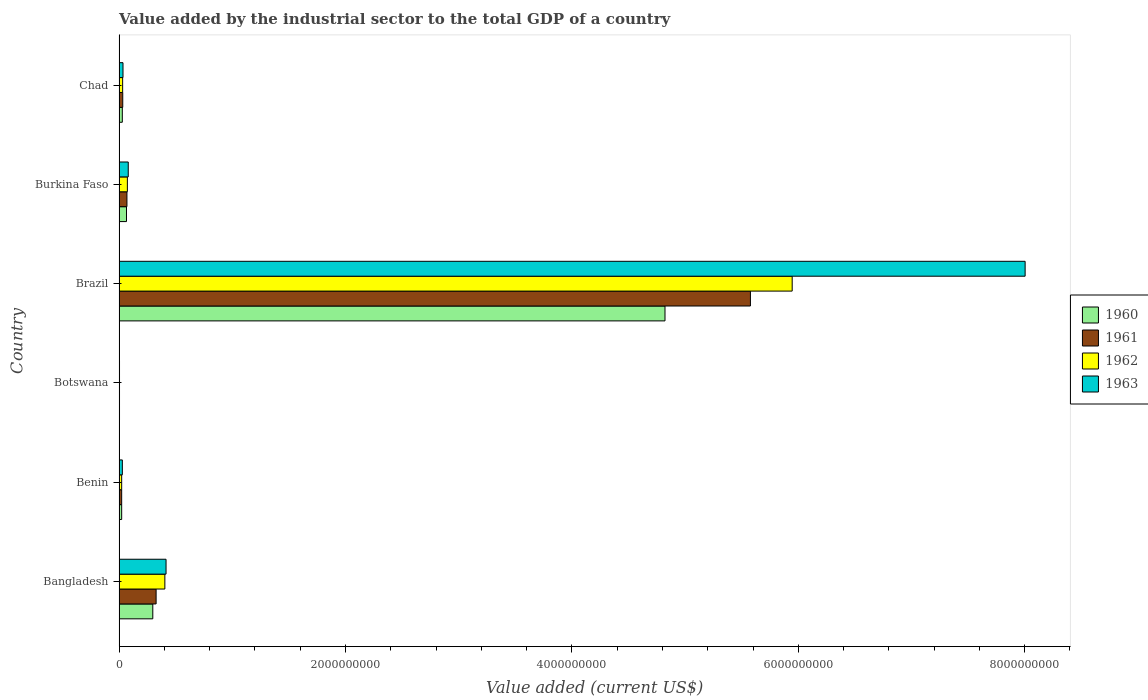How many different coloured bars are there?
Keep it short and to the point. 4. How many groups of bars are there?
Your answer should be very brief. 6. Are the number of bars on each tick of the Y-axis equal?
Give a very brief answer. Yes. How many bars are there on the 5th tick from the top?
Provide a short and direct response. 4. How many bars are there on the 1st tick from the bottom?
Your response must be concise. 4. What is the label of the 5th group of bars from the top?
Keep it short and to the point. Benin. What is the value added by the industrial sector to the total GDP in 1961 in Botswana?
Offer a very short reply. 4.05e+06. Across all countries, what is the maximum value added by the industrial sector to the total GDP in 1962?
Your response must be concise. 5.95e+09. Across all countries, what is the minimum value added by the industrial sector to the total GDP in 1961?
Provide a succinct answer. 4.05e+06. In which country was the value added by the industrial sector to the total GDP in 1960 minimum?
Your answer should be compact. Botswana. What is the total value added by the industrial sector to the total GDP in 1961 in the graph?
Make the answer very short. 6.03e+09. What is the difference between the value added by the industrial sector to the total GDP in 1962 in Botswana and that in Burkina Faso?
Give a very brief answer. -6.95e+07. What is the difference between the value added by the industrial sector to the total GDP in 1960 in Botswana and the value added by the industrial sector to the total GDP in 1963 in Benin?
Provide a short and direct response. -2.51e+07. What is the average value added by the industrial sector to the total GDP in 1960 per country?
Give a very brief answer. 8.74e+08. What is the difference between the value added by the industrial sector to the total GDP in 1963 and value added by the industrial sector to the total GDP in 1961 in Benin?
Keep it short and to the point. 6.00e+06. What is the ratio of the value added by the industrial sector to the total GDP in 1960 in Bangladesh to that in Benin?
Offer a very short reply. 12.89. Is the value added by the industrial sector to the total GDP in 1960 in Bangladesh less than that in Botswana?
Ensure brevity in your answer.  No. What is the difference between the highest and the second highest value added by the industrial sector to the total GDP in 1963?
Offer a very short reply. 7.59e+09. What is the difference between the highest and the lowest value added by the industrial sector to the total GDP in 1961?
Ensure brevity in your answer.  5.57e+09. Is it the case that in every country, the sum of the value added by the industrial sector to the total GDP in 1960 and value added by the industrial sector to the total GDP in 1961 is greater than the sum of value added by the industrial sector to the total GDP in 1963 and value added by the industrial sector to the total GDP in 1962?
Your response must be concise. No. Is it the case that in every country, the sum of the value added by the industrial sector to the total GDP in 1960 and value added by the industrial sector to the total GDP in 1963 is greater than the value added by the industrial sector to the total GDP in 1962?
Make the answer very short. Yes. Are all the bars in the graph horizontal?
Ensure brevity in your answer.  Yes. How many countries are there in the graph?
Provide a succinct answer. 6. What is the difference between two consecutive major ticks on the X-axis?
Keep it short and to the point. 2.00e+09. Are the values on the major ticks of X-axis written in scientific E-notation?
Give a very brief answer. No. Where does the legend appear in the graph?
Provide a succinct answer. Center right. How many legend labels are there?
Keep it short and to the point. 4. How are the legend labels stacked?
Make the answer very short. Vertical. What is the title of the graph?
Your answer should be compact. Value added by the industrial sector to the total GDP of a country. What is the label or title of the X-axis?
Provide a succinct answer. Value added (current US$). What is the label or title of the Y-axis?
Your answer should be very brief. Country. What is the Value added (current US$) of 1960 in Bangladesh?
Your response must be concise. 2.98e+08. What is the Value added (current US$) in 1961 in Bangladesh?
Offer a very short reply. 3.27e+08. What is the Value added (current US$) of 1962 in Bangladesh?
Ensure brevity in your answer.  4.05e+08. What is the Value added (current US$) of 1963 in Bangladesh?
Offer a very short reply. 4.15e+08. What is the Value added (current US$) in 1960 in Benin?
Give a very brief answer. 2.31e+07. What is the Value added (current US$) of 1961 in Benin?
Offer a terse response. 2.31e+07. What is the Value added (current US$) of 1962 in Benin?
Make the answer very short. 2.32e+07. What is the Value added (current US$) in 1963 in Benin?
Keep it short and to the point. 2.91e+07. What is the Value added (current US$) in 1960 in Botswana?
Your answer should be compact. 4.05e+06. What is the Value added (current US$) in 1961 in Botswana?
Your answer should be compact. 4.05e+06. What is the Value added (current US$) of 1962 in Botswana?
Your answer should be compact. 4.05e+06. What is the Value added (current US$) in 1963 in Botswana?
Ensure brevity in your answer.  4.04e+06. What is the Value added (current US$) in 1960 in Brazil?
Provide a short and direct response. 4.82e+09. What is the Value added (current US$) in 1961 in Brazil?
Provide a succinct answer. 5.58e+09. What is the Value added (current US$) in 1962 in Brazil?
Keep it short and to the point. 5.95e+09. What is the Value added (current US$) of 1963 in Brazil?
Make the answer very short. 8.00e+09. What is the Value added (current US$) in 1960 in Burkina Faso?
Offer a very short reply. 6.58e+07. What is the Value added (current US$) of 1961 in Burkina Faso?
Make the answer very short. 6.97e+07. What is the Value added (current US$) in 1962 in Burkina Faso?
Your answer should be very brief. 7.35e+07. What is the Value added (current US$) in 1963 in Burkina Faso?
Offer a terse response. 8.13e+07. What is the Value added (current US$) in 1960 in Chad?
Your answer should be very brief. 2.88e+07. What is the Value added (current US$) in 1961 in Chad?
Your response must be concise. 3.27e+07. What is the Value added (current US$) of 1962 in Chad?
Keep it short and to the point. 3.17e+07. What is the Value added (current US$) of 1963 in Chad?
Your response must be concise. 3.49e+07. Across all countries, what is the maximum Value added (current US$) of 1960?
Provide a succinct answer. 4.82e+09. Across all countries, what is the maximum Value added (current US$) in 1961?
Give a very brief answer. 5.58e+09. Across all countries, what is the maximum Value added (current US$) of 1962?
Make the answer very short. 5.95e+09. Across all countries, what is the maximum Value added (current US$) of 1963?
Provide a succinct answer. 8.00e+09. Across all countries, what is the minimum Value added (current US$) of 1960?
Keep it short and to the point. 4.05e+06. Across all countries, what is the minimum Value added (current US$) of 1961?
Your response must be concise. 4.05e+06. Across all countries, what is the minimum Value added (current US$) in 1962?
Provide a succinct answer. 4.05e+06. Across all countries, what is the minimum Value added (current US$) of 1963?
Your response must be concise. 4.04e+06. What is the total Value added (current US$) in 1960 in the graph?
Keep it short and to the point. 5.24e+09. What is the total Value added (current US$) of 1961 in the graph?
Your answer should be very brief. 6.03e+09. What is the total Value added (current US$) of 1962 in the graph?
Make the answer very short. 6.48e+09. What is the total Value added (current US$) in 1963 in the graph?
Your response must be concise. 8.57e+09. What is the difference between the Value added (current US$) of 1960 in Bangladesh and that in Benin?
Keep it short and to the point. 2.75e+08. What is the difference between the Value added (current US$) in 1961 in Bangladesh and that in Benin?
Your answer should be compact. 3.04e+08. What is the difference between the Value added (current US$) in 1962 in Bangladesh and that in Benin?
Your answer should be very brief. 3.82e+08. What is the difference between the Value added (current US$) in 1963 in Bangladesh and that in Benin?
Keep it short and to the point. 3.86e+08. What is the difference between the Value added (current US$) in 1960 in Bangladesh and that in Botswana?
Offer a terse response. 2.94e+08. What is the difference between the Value added (current US$) in 1961 in Bangladesh and that in Botswana?
Your answer should be very brief. 3.23e+08. What is the difference between the Value added (current US$) in 1962 in Bangladesh and that in Botswana?
Your response must be concise. 4.01e+08. What is the difference between the Value added (current US$) of 1963 in Bangladesh and that in Botswana?
Your response must be concise. 4.11e+08. What is the difference between the Value added (current US$) in 1960 in Bangladesh and that in Brazil?
Make the answer very short. -4.52e+09. What is the difference between the Value added (current US$) in 1961 in Bangladesh and that in Brazil?
Make the answer very short. -5.25e+09. What is the difference between the Value added (current US$) in 1962 in Bangladesh and that in Brazil?
Offer a terse response. -5.54e+09. What is the difference between the Value added (current US$) in 1963 in Bangladesh and that in Brazil?
Provide a succinct answer. -7.59e+09. What is the difference between the Value added (current US$) in 1960 in Bangladesh and that in Burkina Faso?
Give a very brief answer. 2.32e+08. What is the difference between the Value added (current US$) of 1961 in Bangladesh and that in Burkina Faso?
Provide a short and direct response. 2.58e+08. What is the difference between the Value added (current US$) of 1962 in Bangladesh and that in Burkina Faso?
Offer a very short reply. 3.31e+08. What is the difference between the Value added (current US$) in 1963 in Bangladesh and that in Burkina Faso?
Provide a short and direct response. 3.34e+08. What is the difference between the Value added (current US$) of 1960 in Bangladesh and that in Chad?
Provide a succinct answer. 2.69e+08. What is the difference between the Value added (current US$) in 1961 in Bangladesh and that in Chad?
Your response must be concise. 2.95e+08. What is the difference between the Value added (current US$) in 1962 in Bangladesh and that in Chad?
Offer a terse response. 3.73e+08. What is the difference between the Value added (current US$) of 1963 in Bangladesh and that in Chad?
Provide a succinct answer. 3.80e+08. What is the difference between the Value added (current US$) of 1960 in Benin and that in Botswana?
Make the answer very short. 1.91e+07. What is the difference between the Value added (current US$) in 1961 in Benin and that in Botswana?
Keep it short and to the point. 1.91e+07. What is the difference between the Value added (current US$) of 1962 in Benin and that in Botswana?
Your answer should be compact. 1.91e+07. What is the difference between the Value added (current US$) in 1963 in Benin and that in Botswana?
Your answer should be compact. 2.51e+07. What is the difference between the Value added (current US$) of 1960 in Benin and that in Brazil?
Your answer should be compact. -4.80e+09. What is the difference between the Value added (current US$) of 1961 in Benin and that in Brazil?
Your response must be concise. -5.55e+09. What is the difference between the Value added (current US$) in 1962 in Benin and that in Brazil?
Make the answer very short. -5.92e+09. What is the difference between the Value added (current US$) of 1963 in Benin and that in Brazil?
Offer a very short reply. -7.97e+09. What is the difference between the Value added (current US$) in 1960 in Benin and that in Burkina Faso?
Your answer should be very brief. -4.27e+07. What is the difference between the Value added (current US$) of 1961 in Benin and that in Burkina Faso?
Offer a very short reply. -4.66e+07. What is the difference between the Value added (current US$) in 1962 in Benin and that in Burkina Faso?
Offer a terse response. -5.04e+07. What is the difference between the Value added (current US$) in 1963 in Benin and that in Burkina Faso?
Offer a terse response. -5.21e+07. What is the difference between the Value added (current US$) in 1960 in Benin and that in Chad?
Ensure brevity in your answer.  -5.70e+06. What is the difference between the Value added (current US$) in 1961 in Benin and that in Chad?
Keep it short and to the point. -9.53e+06. What is the difference between the Value added (current US$) of 1962 in Benin and that in Chad?
Give a very brief answer. -8.58e+06. What is the difference between the Value added (current US$) of 1963 in Benin and that in Chad?
Your answer should be very brief. -5.75e+06. What is the difference between the Value added (current US$) in 1960 in Botswana and that in Brazil?
Your response must be concise. -4.82e+09. What is the difference between the Value added (current US$) in 1961 in Botswana and that in Brazil?
Keep it short and to the point. -5.57e+09. What is the difference between the Value added (current US$) in 1962 in Botswana and that in Brazil?
Your answer should be compact. -5.94e+09. What is the difference between the Value added (current US$) of 1963 in Botswana and that in Brazil?
Your answer should be compact. -8.00e+09. What is the difference between the Value added (current US$) in 1960 in Botswana and that in Burkina Faso?
Provide a succinct answer. -6.17e+07. What is the difference between the Value added (current US$) of 1961 in Botswana and that in Burkina Faso?
Keep it short and to the point. -6.56e+07. What is the difference between the Value added (current US$) in 1962 in Botswana and that in Burkina Faso?
Your answer should be compact. -6.95e+07. What is the difference between the Value added (current US$) in 1963 in Botswana and that in Burkina Faso?
Provide a succinct answer. -7.72e+07. What is the difference between the Value added (current US$) of 1960 in Botswana and that in Chad?
Your response must be concise. -2.48e+07. What is the difference between the Value added (current US$) of 1961 in Botswana and that in Chad?
Ensure brevity in your answer.  -2.86e+07. What is the difference between the Value added (current US$) in 1962 in Botswana and that in Chad?
Your response must be concise. -2.77e+07. What is the difference between the Value added (current US$) in 1963 in Botswana and that in Chad?
Offer a very short reply. -3.08e+07. What is the difference between the Value added (current US$) of 1960 in Brazil and that in Burkina Faso?
Offer a very short reply. 4.76e+09. What is the difference between the Value added (current US$) in 1961 in Brazil and that in Burkina Faso?
Your answer should be very brief. 5.51e+09. What is the difference between the Value added (current US$) of 1962 in Brazil and that in Burkina Faso?
Offer a terse response. 5.87e+09. What is the difference between the Value added (current US$) of 1963 in Brazil and that in Burkina Faso?
Ensure brevity in your answer.  7.92e+09. What is the difference between the Value added (current US$) of 1960 in Brazil and that in Chad?
Your answer should be compact. 4.79e+09. What is the difference between the Value added (current US$) in 1961 in Brazil and that in Chad?
Ensure brevity in your answer.  5.54e+09. What is the difference between the Value added (current US$) of 1962 in Brazil and that in Chad?
Your answer should be very brief. 5.91e+09. What is the difference between the Value added (current US$) in 1963 in Brazil and that in Chad?
Offer a terse response. 7.97e+09. What is the difference between the Value added (current US$) in 1960 in Burkina Faso and that in Chad?
Your answer should be compact. 3.70e+07. What is the difference between the Value added (current US$) in 1961 in Burkina Faso and that in Chad?
Offer a very short reply. 3.70e+07. What is the difference between the Value added (current US$) of 1962 in Burkina Faso and that in Chad?
Offer a terse response. 4.18e+07. What is the difference between the Value added (current US$) in 1963 in Burkina Faso and that in Chad?
Provide a succinct answer. 4.64e+07. What is the difference between the Value added (current US$) of 1960 in Bangladesh and the Value added (current US$) of 1961 in Benin?
Keep it short and to the point. 2.75e+08. What is the difference between the Value added (current US$) in 1960 in Bangladesh and the Value added (current US$) in 1962 in Benin?
Give a very brief answer. 2.75e+08. What is the difference between the Value added (current US$) in 1960 in Bangladesh and the Value added (current US$) in 1963 in Benin?
Offer a very short reply. 2.69e+08. What is the difference between the Value added (current US$) in 1961 in Bangladesh and the Value added (current US$) in 1962 in Benin?
Provide a short and direct response. 3.04e+08. What is the difference between the Value added (current US$) of 1961 in Bangladesh and the Value added (current US$) of 1963 in Benin?
Offer a very short reply. 2.98e+08. What is the difference between the Value added (current US$) of 1962 in Bangladesh and the Value added (current US$) of 1963 in Benin?
Give a very brief answer. 3.76e+08. What is the difference between the Value added (current US$) of 1960 in Bangladesh and the Value added (current US$) of 1961 in Botswana?
Keep it short and to the point. 2.94e+08. What is the difference between the Value added (current US$) in 1960 in Bangladesh and the Value added (current US$) in 1962 in Botswana?
Ensure brevity in your answer.  2.94e+08. What is the difference between the Value added (current US$) in 1960 in Bangladesh and the Value added (current US$) in 1963 in Botswana?
Ensure brevity in your answer.  2.94e+08. What is the difference between the Value added (current US$) of 1961 in Bangladesh and the Value added (current US$) of 1962 in Botswana?
Your response must be concise. 3.23e+08. What is the difference between the Value added (current US$) of 1961 in Bangladesh and the Value added (current US$) of 1963 in Botswana?
Keep it short and to the point. 3.23e+08. What is the difference between the Value added (current US$) in 1962 in Bangladesh and the Value added (current US$) in 1963 in Botswana?
Give a very brief answer. 4.01e+08. What is the difference between the Value added (current US$) of 1960 in Bangladesh and the Value added (current US$) of 1961 in Brazil?
Ensure brevity in your answer.  -5.28e+09. What is the difference between the Value added (current US$) in 1960 in Bangladesh and the Value added (current US$) in 1962 in Brazil?
Keep it short and to the point. -5.65e+09. What is the difference between the Value added (current US$) in 1960 in Bangladesh and the Value added (current US$) in 1963 in Brazil?
Keep it short and to the point. -7.71e+09. What is the difference between the Value added (current US$) of 1961 in Bangladesh and the Value added (current US$) of 1962 in Brazil?
Offer a very short reply. -5.62e+09. What is the difference between the Value added (current US$) in 1961 in Bangladesh and the Value added (current US$) in 1963 in Brazil?
Keep it short and to the point. -7.68e+09. What is the difference between the Value added (current US$) in 1962 in Bangladesh and the Value added (current US$) in 1963 in Brazil?
Your answer should be very brief. -7.60e+09. What is the difference between the Value added (current US$) of 1960 in Bangladesh and the Value added (current US$) of 1961 in Burkina Faso?
Provide a succinct answer. 2.28e+08. What is the difference between the Value added (current US$) in 1960 in Bangladesh and the Value added (current US$) in 1962 in Burkina Faso?
Your response must be concise. 2.25e+08. What is the difference between the Value added (current US$) in 1960 in Bangladesh and the Value added (current US$) in 1963 in Burkina Faso?
Ensure brevity in your answer.  2.17e+08. What is the difference between the Value added (current US$) of 1961 in Bangladesh and the Value added (current US$) of 1962 in Burkina Faso?
Offer a terse response. 2.54e+08. What is the difference between the Value added (current US$) of 1961 in Bangladesh and the Value added (current US$) of 1963 in Burkina Faso?
Give a very brief answer. 2.46e+08. What is the difference between the Value added (current US$) in 1962 in Bangladesh and the Value added (current US$) in 1963 in Burkina Faso?
Offer a very short reply. 3.23e+08. What is the difference between the Value added (current US$) of 1960 in Bangladesh and the Value added (current US$) of 1961 in Chad?
Your answer should be very brief. 2.65e+08. What is the difference between the Value added (current US$) of 1960 in Bangladesh and the Value added (current US$) of 1962 in Chad?
Offer a very short reply. 2.66e+08. What is the difference between the Value added (current US$) in 1960 in Bangladesh and the Value added (current US$) in 1963 in Chad?
Provide a succinct answer. 2.63e+08. What is the difference between the Value added (current US$) of 1961 in Bangladesh and the Value added (current US$) of 1962 in Chad?
Give a very brief answer. 2.96e+08. What is the difference between the Value added (current US$) of 1961 in Bangladesh and the Value added (current US$) of 1963 in Chad?
Offer a terse response. 2.92e+08. What is the difference between the Value added (current US$) of 1962 in Bangladesh and the Value added (current US$) of 1963 in Chad?
Provide a short and direct response. 3.70e+08. What is the difference between the Value added (current US$) of 1960 in Benin and the Value added (current US$) of 1961 in Botswana?
Give a very brief answer. 1.91e+07. What is the difference between the Value added (current US$) in 1960 in Benin and the Value added (current US$) in 1962 in Botswana?
Offer a very short reply. 1.91e+07. What is the difference between the Value added (current US$) of 1960 in Benin and the Value added (current US$) of 1963 in Botswana?
Your answer should be very brief. 1.91e+07. What is the difference between the Value added (current US$) of 1961 in Benin and the Value added (current US$) of 1962 in Botswana?
Provide a short and direct response. 1.91e+07. What is the difference between the Value added (current US$) of 1961 in Benin and the Value added (current US$) of 1963 in Botswana?
Provide a short and direct response. 1.91e+07. What is the difference between the Value added (current US$) of 1962 in Benin and the Value added (current US$) of 1963 in Botswana?
Provide a short and direct response. 1.91e+07. What is the difference between the Value added (current US$) of 1960 in Benin and the Value added (current US$) of 1961 in Brazil?
Your answer should be compact. -5.55e+09. What is the difference between the Value added (current US$) in 1960 in Benin and the Value added (current US$) in 1962 in Brazil?
Offer a terse response. -5.92e+09. What is the difference between the Value added (current US$) of 1960 in Benin and the Value added (current US$) of 1963 in Brazil?
Your response must be concise. -7.98e+09. What is the difference between the Value added (current US$) of 1961 in Benin and the Value added (current US$) of 1962 in Brazil?
Keep it short and to the point. -5.92e+09. What is the difference between the Value added (current US$) in 1961 in Benin and the Value added (current US$) in 1963 in Brazil?
Provide a short and direct response. -7.98e+09. What is the difference between the Value added (current US$) in 1962 in Benin and the Value added (current US$) in 1963 in Brazil?
Keep it short and to the point. -7.98e+09. What is the difference between the Value added (current US$) of 1960 in Benin and the Value added (current US$) of 1961 in Burkina Faso?
Your answer should be very brief. -4.65e+07. What is the difference between the Value added (current US$) of 1960 in Benin and the Value added (current US$) of 1962 in Burkina Faso?
Ensure brevity in your answer.  -5.04e+07. What is the difference between the Value added (current US$) of 1960 in Benin and the Value added (current US$) of 1963 in Burkina Faso?
Provide a succinct answer. -5.81e+07. What is the difference between the Value added (current US$) of 1961 in Benin and the Value added (current US$) of 1962 in Burkina Faso?
Your response must be concise. -5.04e+07. What is the difference between the Value added (current US$) in 1961 in Benin and the Value added (current US$) in 1963 in Burkina Faso?
Keep it short and to the point. -5.81e+07. What is the difference between the Value added (current US$) in 1962 in Benin and the Value added (current US$) in 1963 in Burkina Faso?
Provide a short and direct response. -5.81e+07. What is the difference between the Value added (current US$) of 1960 in Benin and the Value added (current US$) of 1961 in Chad?
Ensure brevity in your answer.  -9.52e+06. What is the difference between the Value added (current US$) in 1960 in Benin and the Value added (current US$) in 1962 in Chad?
Offer a very short reply. -8.60e+06. What is the difference between the Value added (current US$) in 1960 in Benin and the Value added (current US$) in 1963 in Chad?
Ensure brevity in your answer.  -1.17e+07. What is the difference between the Value added (current US$) in 1961 in Benin and the Value added (current US$) in 1962 in Chad?
Provide a short and direct response. -8.61e+06. What is the difference between the Value added (current US$) of 1961 in Benin and the Value added (current US$) of 1963 in Chad?
Your answer should be very brief. -1.17e+07. What is the difference between the Value added (current US$) of 1962 in Benin and the Value added (current US$) of 1963 in Chad?
Offer a terse response. -1.17e+07. What is the difference between the Value added (current US$) of 1960 in Botswana and the Value added (current US$) of 1961 in Brazil?
Provide a succinct answer. -5.57e+09. What is the difference between the Value added (current US$) in 1960 in Botswana and the Value added (current US$) in 1962 in Brazil?
Offer a very short reply. -5.94e+09. What is the difference between the Value added (current US$) of 1960 in Botswana and the Value added (current US$) of 1963 in Brazil?
Provide a succinct answer. -8.00e+09. What is the difference between the Value added (current US$) in 1961 in Botswana and the Value added (current US$) in 1962 in Brazil?
Provide a short and direct response. -5.94e+09. What is the difference between the Value added (current US$) of 1961 in Botswana and the Value added (current US$) of 1963 in Brazil?
Your answer should be compact. -8.00e+09. What is the difference between the Value added (current US$) of 1962 in Botswana and the Value added (current US$) of 1963 in Brazil?
Keep it short and to the point. -8.00e+09. What is the difference between the Value added (current US$) in 1960 in Botswana and the Value added (current US$) in 1961 in Burkina Faso?
Your answer should be very brief. -6.56e+07. What is the difference between the Value added (current US$) in 1960 in Botswana and the Value added (current US$) in 1962 in Burkina Faso?
Ensure brevity in your answer.  -6.95e+07. What is the difference between the Value added (current US$) in 1960 in Botswana and the Value added (current US$) in 1963 in Burkina Faso?
Ensure brevity in your answer.  -7.72e+07. What is the difference between the Value added (current US$) of 1961 in Botswana and the Value added (current US$) of 1962 in Burkina Faso?
Keep it short and to the point. -6.95e+07. What is the difference between the Value added (current US$) of 1961 in Botswana and the Value added (current US$) of 1963 in Burkina Faso?
Give a very brief answer. -7.72e+07. What is the difference between the Value added (current US$) of 1962 in Botswana and the Value added (current US$) of 1963 in Burkina Faso?
Your answer should be compact. -7.72e+07. What is the difference between the Value added (current US$) of 1960 in Botswana and the Value added (current US$) of 1961 in Chad?
Provide a succinct answer. -2.86e+07. What is the difference between the Value added (current US$) in 1960 in Botswana and the Value added (current US$) in 1962 in Chad?
Provide a short and direct response. -2.77e+07. What is the difference between the Value added (current US$) in 1960 in Botswana and the Value added (current US$) in 1963 in Chad?
Offer a terse response. -3.08e+07. What is the difference between the Value added (current US$) of 1961 in Botswana and the Value added (current US$) of 1962 in Chad?
Provide a succinct answer. -2.77e+07. What is the difference between the Value added (current US$) in 1961 in Botswana and the Value added (current US$) in 1963 in Chad?
Provide a succinct answer. -3.08e+07. What is the difference between the Value added (current US$) of 1962 in Botswana and the Value added (current US$) of 1963 in Chad?
Provide a short and direct response. -3.08e+07. What is the difference between the Value added (current US$) in 1960 in Brazil and the Value added (current US$) in 1961 in Burkina Faso?
Offer a terse response. 4.75e+09. What is the difference between the Value added (current US$) of 1960 in Brazil and the Value added (current US$) of 1962 in Burkina Faso?
Provide a short and direct response. 4.75e+09. What is the difference between the Value added (current US$) in 1960 in Brazil and the Value added (current US$) in 1963 in Burkina Faso?
Make the answer very short. 4.74e+09. What is the difference between the Value added (current US$) of 1961 in Brazil and the Value added (current US$) of 1962 in Burkina Faso?
Provide a succinct answer. 5.50e+09. What is the difference between the Value added (current US$) in 1961 in Brazil and the Value added (current US$) in 1963 in Burkina Faso?
Your answer should be very brief. 5.50e+09. What is the difference between the Value added (current US$) of 1962 in Brazil and the Value added (current US$) of 1963 in Burkina Faso?
Make the answer very short. 5.86e+09. What is the difference between the Value added (current US$) of 1960 in Brazil and the Value added (current US$) of 1961 in Chad?
Provide a succinct answer. 4.79e+09. What is the difference between the Value added (current US$) of 1960 in Brazil and the Value added (current US$) of 1962 in Chad?
Offer a very short reply. 4.79e+09. What is the difference between the Value added (current US$) in 1960 in Brazil and the Value added (current US$) in 1963 in Chad?
Your answer should be very brief. 4.79e+09. What is the difference between the Value added (current US$) in 1961 in Brazil and the Value added (current US$) in 1962 in Chad?
Your answer should be very brief. 5.55e+09. What is the difference between the Value added (current US$) in 1961 in Brazil and the Value added (current US$) in 1963 in Chad?
Your response must be concise. 5.54e+09. What is the difference between the Value added (current US$) in 1962 in Brazil and the Value added (current US$) in 1963 in Chad?
Keep it short and to the point. 5.91e+09. What is the difference between the Value added (current US$) in 1960 in Burkina Faso and the Value added (current US$) in 1961 in Chad?
Give a very brief answer. 3.32e+07. What is the difference between the Value added (current US$) of 1960 in Burkina Faso and the Value added (current US$) of 1962 in Chad?
Ensure brevity in your answer.  3.41e+07. What is the difference between the Value added (current US$) in 1960 in Burkina Faso and the Value added (current US$) in 1963 in Chad?
Your answer should be compact. 3.09e+07. What is the difference between the Value added (current US$) of 1961 in Burkina Faso and the Value added (current US$) of 1962 in Chad?
Offer a very short reply. 3.79e+07. What is the difference between the Value added (current US$) of 1961 in Burkina Faso and the Value added (current US$) of 1963 in Chad?
Keep it short and to the point. 3.48e+07. What is the difference between the Value added (current US$) in 1962 in Burkina Faso and the Value added (current US$) in 1963 in Chad?
Your answer should be very brief. 3.86e+07. What is the average Value added (current US$) of 1960 per country?
Your response must be concise. 8.74e+08. What is the average Value added (current US$) of 1961 per country?
Provide a short and direct response. 1.01e+09. What is the average Value added (current US$) of 1962 per country?
Your answer should be compact. 1.08e+09. What is the average Value added (current US$) of 1963 per country?
Your response must be concise. 1.43e+09. What is the difference between the Value added (current US$) in 1960 and Value added (current US$) in 1961 in Bangladesh?
Ensure brevity in your answer.  -2.92e+07. What is the difference between the Value added (current US$) in 1960 and Value added (current US$) in 1962 in Bangladesh?
Offer a very short reply. -1.07e+08. What is the difference between the Value added (current US$) of 1960 and Value added (current US$) of 1963 in Bangladesh?
Ensure brevity in your answer.  -1.17e+08. What is the difference between the Value added (current US$) in 1961 and Value added (current US$) in 1962 in Bangladesh?
Your answer should be very brief. -7.74e+07. What is the difference between the Value added (current US$) in 1961 and Value added (current US$) in 1963 in Bangladesh?
Make the answer very short. -8.78e+07. What is the difference between the Value added (current US$) in 1962 and Value added (current US$) in 1963 in Bangladesh?
Offer a terse response. -1.05e+07. What is the difference between the Value added (current US$) in 1960 and Value added (current US$) in 1961 in Benin?
Offer a terse response. 6130.83. What is the difference between the Value added (current US$) of 1960 and Value added (current US$) of 1962 in Benin?
Offer a terse response. -1.71e+04. What is the difference between the Value added (current US$) of 1960 and Value added (current US$) of 1963 in Benin?
Offer a terse response. -5.99e+06. What is the difference between the Value added (current US$) of 1961 and Value added (current US$) of 1962 in Benin?
Your answer should be very brief. -2.32e+04. What is the difference between the Value added (current US$) of 1961 and Value added (current US$) of 1963 in Benin?
Make the answer very short. -6.00e+06. What is the difference between the Value added (current US$) in 1962 and Value added (current US$) in 1963 in Benin?
Provide a succinct answer. -5.97e+06. What is the difference between the Value added (current US$) of 1960 and Value added (current US$) of 1961 in Botswana?
Your answer should be very brief. 7791.27. What is the difference between the Value added (current US$) of 1960 and Value added (current US$) of 1962 in Botswana?
Offer a terse response. -314.81. What is the difference between the Value added (current US$) of 1960 and Value added (current US$) of 1963 in Botswana?
Ensure brevity in your answer.  1.11e+04. What is the difference between the Value added (current US$) of 1961 and Value added (current US$) of 1962 in Botswana?
Ensure brevity in your answer.  -8106.08. What is the difference between the Value added (current US$) in 1961 and Value added (current US$) in 1963 in Botswana?
Give a very brief answer. 3353.04. What is the difference between the Value added (current US$) in 1962 and Value added (current US$) in 1963 in Botswana?
Give a very brief answer. 1.15e+04. What is the difference between the Value added (current US$) in 1960 and Value added (current US$) in 1961 in Brazil?
Provide a short and direct response. -7.55e+08. What is the difference between the Value added (current US$) of 1960 and Value added (current US$) of 1962 in Brazil?
Give a very brief answer. -1.12e+09. What is the difference between the Value added (current US$) of 1960 and Value added (current US$) of 1963 in Brazil?
Your answer should be compact. -3.18e+09. What is the difference between the Value added (current US$) of 1961 and Value added (current US$) of 1962 in Brazil?
Keep it short and to the point. -3.69e+08. What is the difference between the Value added (current US$) of 1961 and Value added (current US$) of 1963 in Brazil?
Ensure brevity in your answer.  -2.43e+09. What is the difference between the Value added (current US$) in 1962 and Value added (current US$) in 1963 in Brazil?
Ensure brevity in your answer.  -2.06e+09. What is the difference between the Value added (current US$) of 1960 and Value added (current US$) of 1961 in Burkina Faso?
Offer a terse response. -3.88e+06. What is the difference between the Value added (current US$) of 1960 and Value added (current US$) of 1962 in Burkina Faso?
Offer a very short reply. -7.71e+06. What is the difference between the Value added (current US$) of 1960 and Value added (current US$) of 1963 in Burkina Faso?
Ensure brevity in your answer.  -1.55e+07. What is the difference between the Value added (current US$) of 1961 and Value added (current US$) of 1962 in Burkina Faso?
Provide a short and direct response. -3.83e+06. What is the difference between the Value added (current US$) of 1961 and Value added (current US$) of 1963 in Burkina Faso?
Offer a very short reply. -1.16e+07. What is the difference between the Value added (current US$) of 1962 and Value added (current US$) of 1963 in Burkina Faso?
Offer a very short reply. -7.75e+06. What is the difference between the Value added (current US$) in 1960 and Value added (current US$) in 1961 in Chad?
Your answer should be compact. -3.82e+06. What is the difference between the Value added (current US$) in 1960 and Value added (current US$) in 1962 in Chad?
Provide a succinct answer. -2.90e+06. What is the difference between the Value added (current US$) of 1960 and Value added (current US$) of 1963 in Chad?
Your response must be concise. -6.04e+06. What is the difference between the Value added (current US$) of 1961 and Value added (current US$) of 1962 in Chad?
Your response must be concise. 9.19e+05. What is the difference between the Value added (current US$) in 1961 and Value added (current US$) in 1963 in Chad?
Your answer should be compact. -2.22e+06. What is the difference between the Value added (current US$) in 1962 and Value added (current US$) in 1963 in Chad?
Give a very brief answer. -3.14e+06. What is the ratio of the Value added (current US$) of 1960 in Bangladesh to that in Benin?
Your answer should be compact. 12.89. What is the ratio of the Value added (current US$) in 1961 in Bangladesh to that in Benin?
Offer a terse response. 14.15. What is the ratio of the Value added (current US$) in 1962 in Bangladesh to that in Benin?
Your response must be concise. 17.48. What is the ratio of the Value added (current US$) in 1963 in Bangladesh to that in Benin?
Provide a short and direct response. 14.26. What is the ratio of the Value added (current US$) in 1960 in Bangladesh to that in Botswana?
Ensure brevity in your answer.  73.54. What is the ratio of the Value added (current US$) in 1961 in Bangladesh to that in Botswana?
Provide a succinct answer. 80.89. What is the ratio of the Value added (current US$) in 1962 in Bangladesh to that in Botswana?
Provide a short and direct response. 99.81. What is the ratio of the Value added (current US$) of 1963 in Bangladesh to that in Botswana?
Provide a succinct answer. 102.69. What is the ratio of the Value added (current US$) in 1960 in Bangladesh to that in Brazil?
Provide a succinct answer. 0.06. What is the ratio of the Value added (current US$) in 1961 in Bangladesh to that in Brazil?
Your answer should be very brief. 0.06. What is the ratio of the Value added (current US$) in 1962 in Bangladesh to that in Brazil?
Make the answer very short. 0.07. What is the ratio of the Value added (current US$) in 1963 in Bangladesh to that in Brazil?
Give a very brief answer. 0.05. What is the ratio of the Value added (current US$) in 1960 in Bangladesh to that in Burkina Faso?
Keep it short and to the point. 4.53. What is the ratio of the Value added (current US$) in 1961 in Bangladesh to that in Burkina Faso?
Keep it short and to the point. 4.7. What is the ratio of the Value added (current US$) of 1962 in Bangladesh to that in Burkina Faso?
Give a very brief answer. 5.5. What is the ratio of the Value added (current US$) in 1963 in Bangladesh to that in Burkina Faso?
Make the answer very short. 5.11. What is the ratio of the Value added (current US$) in 1960 in Bangladesh to that in Chad?
Offer a very short reply. 10.34. What is the ratio of the Value added (current US$) of 1961 in Bangladesh to that in Chad?
Provide a short and direct response. 10.02. What is the ratio of the Value added (current US$) of 1962 in Bangladesh to that in Chad?
Provide a succinct answer. 12.75. What is the ratio of the Value added (current US$) in 1963 in Bangladesh to that in Chad?
Make the answer very short. 11.91. What is the ratio of the Value added (current US$) of 1960 in Benin to that in Botswana?
Offer a terse response. 5.71. What is the ratio of the Value added (current US$) of 1961 in Benin to that in Botswana?
Make the answer very short. 5.72. What is the ratio of the Value added (current US$) in 1962 in Benin to that in Botswana?
Your answer should be very brief. 5.71. What is the ratio of the Value added (current US$) of 1963 in Benin to that in Botswana?
Offer a very short reply. 7.2. What is the ratio of the Value added (current US$) of 1960 in Benin to that in Brazil?
Offer a very short reply. 0. What is the ratio of the Value added (current US$) of 1961 in Benin to that in Brazil?
Give a very brief answer. 0. What is the ratio of the Value added (current US$) in 1962 in Benin to that in Brazil?
Provide a short and direct response. 0. What is the ratio of the Value added (current US$) of 1963 in Benin to that in Brazil?
Your answer should be compact. 0. What is the ratio of the Value added (current US$) of 1960 in Benin to that in Burkina Faso?
Make the answer very short. 0.35. What is the ratio of the Value added (current US$) of 1961 in Benin to that in Burkina Faso?
Your response must be concise. 0.33. What is the ratio of the Value added (current US$) in 1962 in Benin to that in Burkina Faso?
Offer a very short reply. 0.31. What is the ratio of the Value added (current US$) of 1963 in Benin to that in Burkina Faso?
Offer a terse response. 0.36. What is the ratio of the Value added (current US$) in 1960 in Benin to that in Chad?
Keep it short and to the point. 0.8. What is the ratio of the Value added (current US$) in 1961 in Benin to that in Chad?
Ensure brevity in your answer.  0.71. What is the ratio of the Value added (current US$) of 1962 in Benin to that in Chad?
Make the answer very short. 0.73. What is the ratio of the Value added (current US$) in 1963 in Benin to that in Chad?
Your answer should be very brief. 0.84. What is the ratio of the Value added (current US$) in 1960 in Botswana to that in Brazil?
Your response must be concise. 0. What is the ratio of the Value added (current US$) in 1961 in Botswana to that in Brazil?
Keep it short and to the point. 0. What is the ratio of the Value added (current US$) in 1962 in Botswana to that in Brazil?
Give a very brief answer. 0. What is the ratio of the Value added (current US$) of 1963 in Botswana to that in Brazil?
Make the answer very short. 0. What is the ratio of the Value added (current US$) of 1960 in Botswana to that in Burkina Faso?
Make the answer very short. 0.06. What is the ratio of the Value added (current US$) in 1961 in Botswana to that in Burkina Faso?
Your answer should be compact. 0.06. What is the ratio of the Value added (current US$) in 1962 in Botswana to that in Burkina Faso?
Provide a succinct answer. 0.06. What is the ratio of the Value added (current US$) of 1963 in Botswana to that in Burkina Faso?
Provide a short and direct response. 0.05. What is the ratio of the Value added (current US$) in 1960 in Botswana to that in Chad?
Your answer should be very brief. 0.14. What is the ratio of the Value added (current US$) in 1961 in Botswana to that in Chad?
Offer a very short reply. 0.12. What is the ratio of the Value added (current US$) of 1962 in Botswana to that in Chad?
Your answer should be very brief. 0.13. What is the ratio of the Value added (current US$) of 1963 in Botswana to that in Chad?
Keep it short and to the point. 0.12. What is the ratio of the Value added (current US$) in 1960 in Brazil to that in Burkina Faso?
Make the answer very short. 73.29. What is the ratio of the Value added (current US$) of 1961 in Brazil to that in Burkina Faso?
Provide a succinct answer. 80.04. What is the ratio of the Value added (current US$) in 1962 in Brazil to that in Burkina Faso?
Provide a succinct answer. 80.89. What is the ratio of the Value added (current US$) in 1963 in Brazil to that in Burkina Faso?
Give a very brief answer. 98.49. What is the ratio of the Value added (current US$) of 1960 in Brazil to that in Chad?
Keep it short and to the point. 167.26. What is the ratio of the Value added (current US$) in 1961 in Brazil to that in Chad?
Provide a succinct answer. 170.8. What is the ratio of the Value added (current US$) of 1962 in Brazil to that in Chad?
Your answer should be compact. 187.38. What is the ratio of the Value added (current US$) of 1963 in Brazil to that in Chad?
Provide a succinct answer. 229.53. What is the ratio of the Value added (current US$) in 1960 in Burkina Faso to that in Chad?
Make the answer very short. 2.28. What is the ratio of the Value added (current US$) of 1961 in Burkina Faso to that in Chad?
Provide a succinct answer. 2.13. What is the ratio of the Value added (current US$) of 1962 in Burkina Faso to that in Chad?
Offer a very short reply. 2.32. What is the ratio of the Value added (current US$) of 1963 in Burkina Faso to that in Chad?
Provide a short and direct response. 2.33. What is the difference between the highest and the second highest Value added (current US$) of 1960?
Ensure brevity in your answer.  4.52e+09. What is the difference between the highest and the second highest Value added (current US$) in 1961?
Keep it short and to the point. 5.25e+09. What is the difference between the highest and the second highest Value added (current US$) in 1962?
Your answer should be compact. 5.54e+09. What is the difference between the highest and the second highest Value added (current US$) in 1963?
Offer a very short reply. 7.59e+09. What is the difference between the highest and the lowest Value added (current US$) of 1960?
Provide a succinct answer. 4.82e+09. What is the difference between the highest and the lowest Value added (current US$) of 1961?
Your answer should be very brief. 5.57e+09. What is the difference between the highest and the lowest Value added (current US$) in 1962?
Your answer should be very brief. 5.94e+09. What is the difference between the highest and the lowest Value added (current US$) of 1963?
Your answer should be compact. 8.00e+09. 